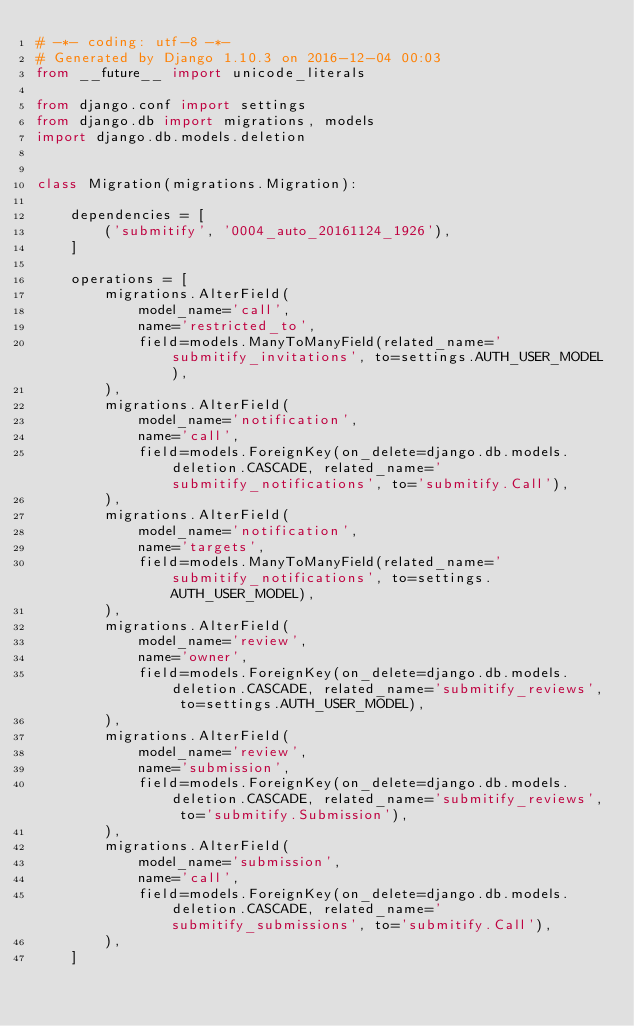<code> <loc_0><loc_0><loc_500><loc_500><_Python_># -*- coding: utf-8 -*-
# Generated by Django 1.10.3 on 2016-12-04 00:03
from __future__ import unicode_literals

from django.conf import settings
from django.db import migrations, models
import django.db.models.deletion


class Migration(migrations.Migration):

    dependencies = [
        ('submitify', '0004_auto_20161124_1926'),
    ]

    operations = [
        migrations.AlterField(
            model_name='call',
            name='restricted_to',
            field=models.ManyToManyField(related_name='submitify_invitations', to=settings.AUTH_USER_MODEL),
        ),
        migrations.AlterField(
            model_name='notification',
            name='call',
            field=models.ForeignKey(on_delete=django.db.models.deletion.CASCADE, related_name='submitify_notifications', to='submitify.Call'),
        ),
        migrations.AlterField(
            model_name='notification',
            name='targets',
            field=models.ManyToManyField(related_name='submitify_notifications', to=settings.AUTH_USER_MODEL),
        ),
        migrations.AlterField(
            model_name='review',
            name='owner',
            field=models.ForeignKey(on_delete=django.db.models.deletion.CASCADE, related_name='submitify_reviews', to=settings.AUTH_USER_MODEL),
        ),
        migrations.AlterField(
            model_name='review',
            name='submission',
            field=models.ForeignKey(on_delete=django.db.models.deletion.CASCADE, related_name='submitify_reviews', to='submitify.Submission'),
        ),
        migrations.AlterField(
            model_name='submission',
            name='call',
            field=models.ForeignKey(on_delete=django.db.models.deletion.CASCADE, related_name='submitify_submissions', to='submitify.Call'),
        ),
    ]
</code> 